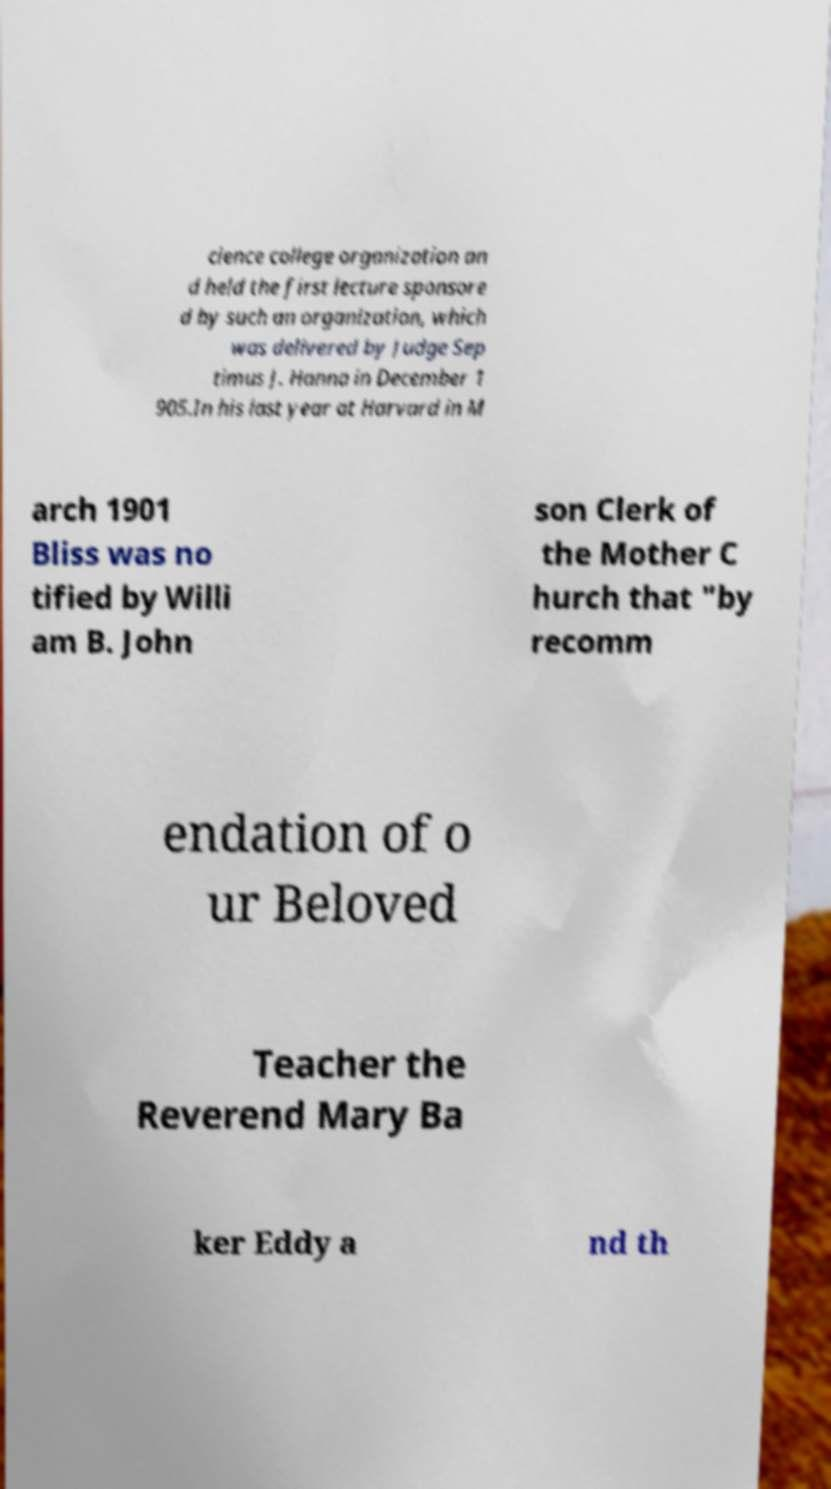For documentation purposes, I need the text within this image transcribed. Could you provide that? cience college organization an d held the first lecture sponsore d by such an organization, which was delivered by Judge Sep timus J. Hanna in December 1 905.In his last year at Harvard in M arch 1901 Bliss was no tified by Willi am B. John son Clerk of the Mother C hurch that "by recomm endation of o ur Beloved Teacher the Reverend Mary Ba ker Eddy a nd th 